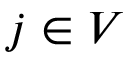Convert formula to latex. <formula><loc_0><loc_0><loc_500><loc_500>j \in V</formula> 